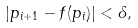<formula> <loc_0><loc_0><loc_500><loc_500>| p _ { i + 1 } - f ( p _ { i } ) | < \delta ,</formula> 